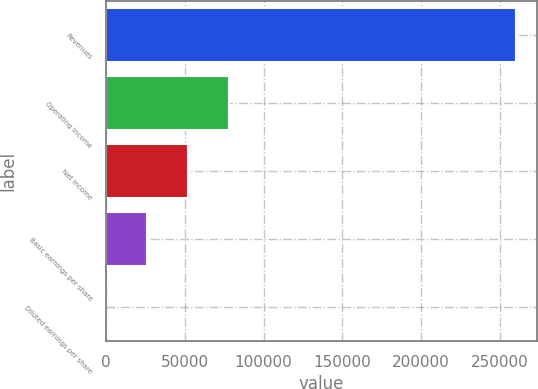Convert chart to OTSL. <chart><loc_0><loc_0><loc_500><loc_500><bar_chart><fcel>Revenues<fcel>Operating income<fcel>Net income<fcel>Basic earnings per share<fcel>Diluted earnings per share<nl><fcel>260418<fcel>78125.7<fcel>52083.9<fcel>26042.2<fcel>0.42<nl></chart> 